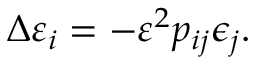<formula> <loc_0><loc_0><loc_500><loc_500>\Delta \varepsilon _ { i } = - \varepsilon ^ { 2 } p _ { i j } \epsilon _ { j } .</formula> 